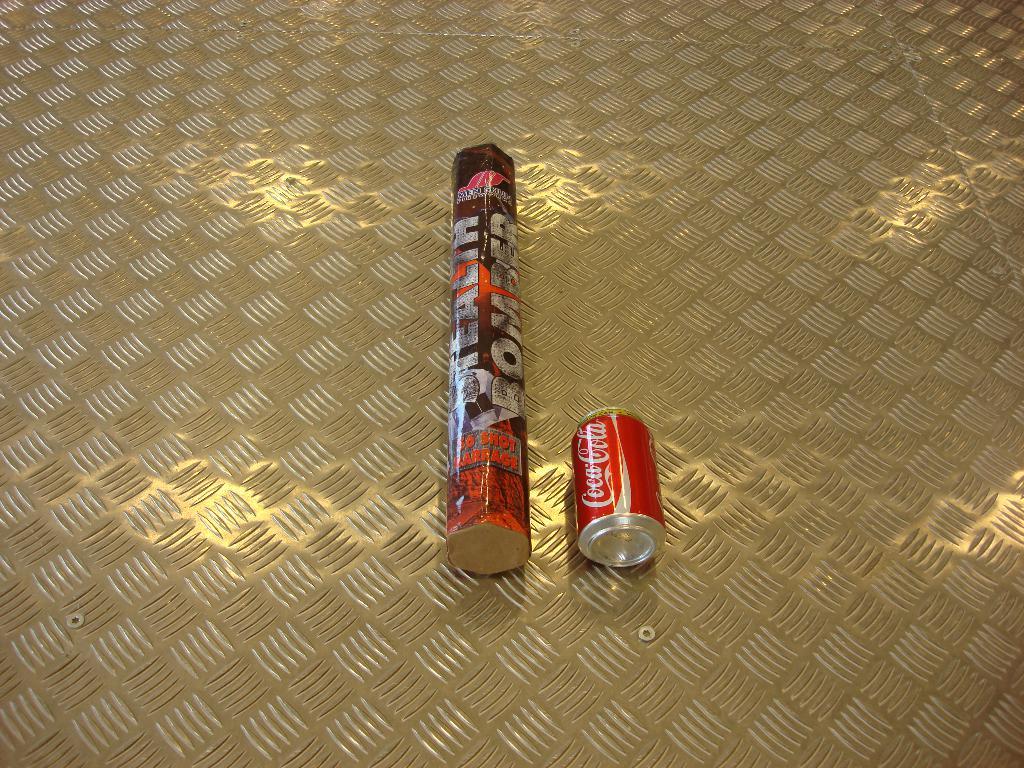What is written vertically on the long item?
Your answer should be compact. Bomber. 